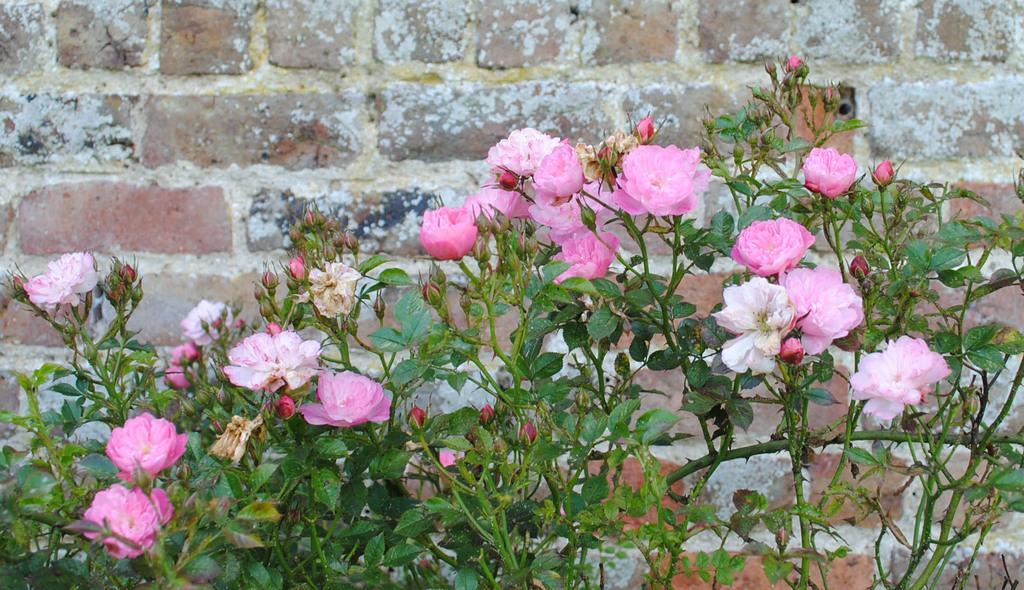Describe this image in one or two sentences. In this picture we can see pink flower plant in the front. behind there is a brick wall. 